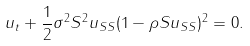<formula> <loc_0><loc_0><loc_500><loc_500>u _ { t } + \frac { 1 } { 2 } \sigma ^ { 2 } S ^ { 2 } u _ { S S } ( 1 - \rho S u _ { S S } ) ^ { 2 } = 0 .</formula> 